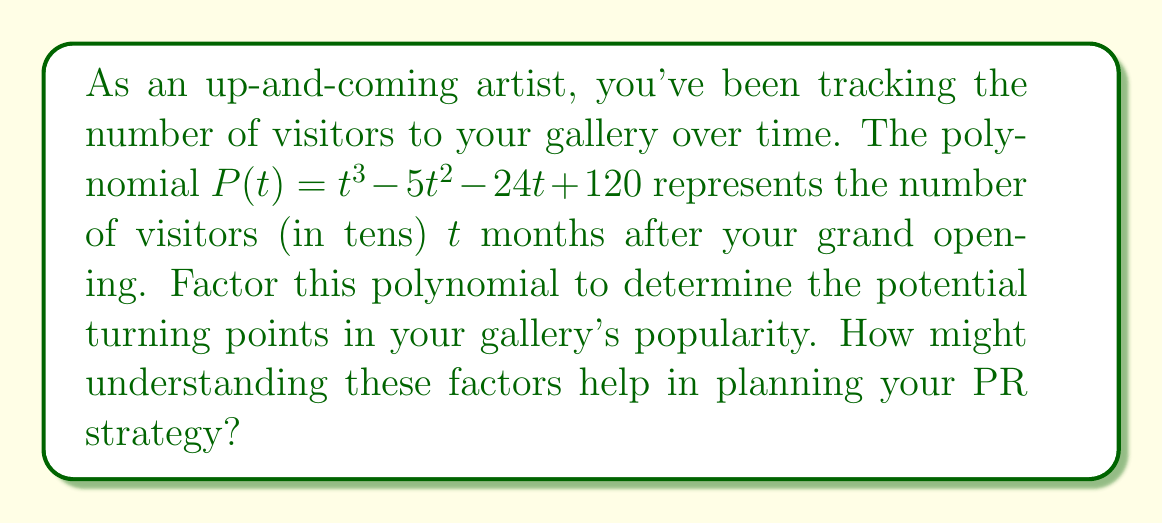Help me with this question. Let's approach this step-by-step:

1) First, we need to factor the polynomial $P(t) = t^3 - 5t^2 - 24t + 120$.

2) We can start by trying to find a factor. Let's check some factors of the constant term, 120. 
   Possible factors: ±1, ±2, ±3, ±4, ±5, ±6, ±8, ±10, ±12, ±15, ±20, ±24, ±30, ±40, ±60, ±120

3) After some trial and error, we find that $(t - 8)$ is a factor.

4) Dividing $P(t)$ by $(t - 8)$:

   $$\frac{t^3 - 5t^2 - 24t + 120}{t - 8} = t^2 + 3t - 15$$

5) So, $P(t) = (t - 8)(t^2 + 3t - 15)$

6) Now we need to factor $t^2 + 3t - 15$. This is a quadratic expression.

7) Using the quadratic formula or factoring by grouping, we get:
   $t^2 + 3t - 15 = (t + 5)(t - 2)$

8) Therefore, the complete factorization is:
   $P(t) = (t - 8)(t + 5)(t - 2)$

Understanding these factors can help in planning your PR strategy:
- The roots of the polynomial (8, -5, and 2) represent potential turning points in your gallery's popularity.
- The positive root at t = 8 might indicate a peak in visitors after 8 months, suggesting a good time for a special event.
- The negative root at t = -5 is not relevant for future planning but might represent a theoretical low point.
- The root at t = 2 could indicate an early fluctuation in visitor numbers, perhaps after initial opening excitement has waned.

By understanding these potential turning points, you can plan PR initiatives to maintain interest during potential lulls and capitalize on periods of high visitor numbers.
Answer: $P(t) = (t - 8)(t + 5)(t - 2)$ 